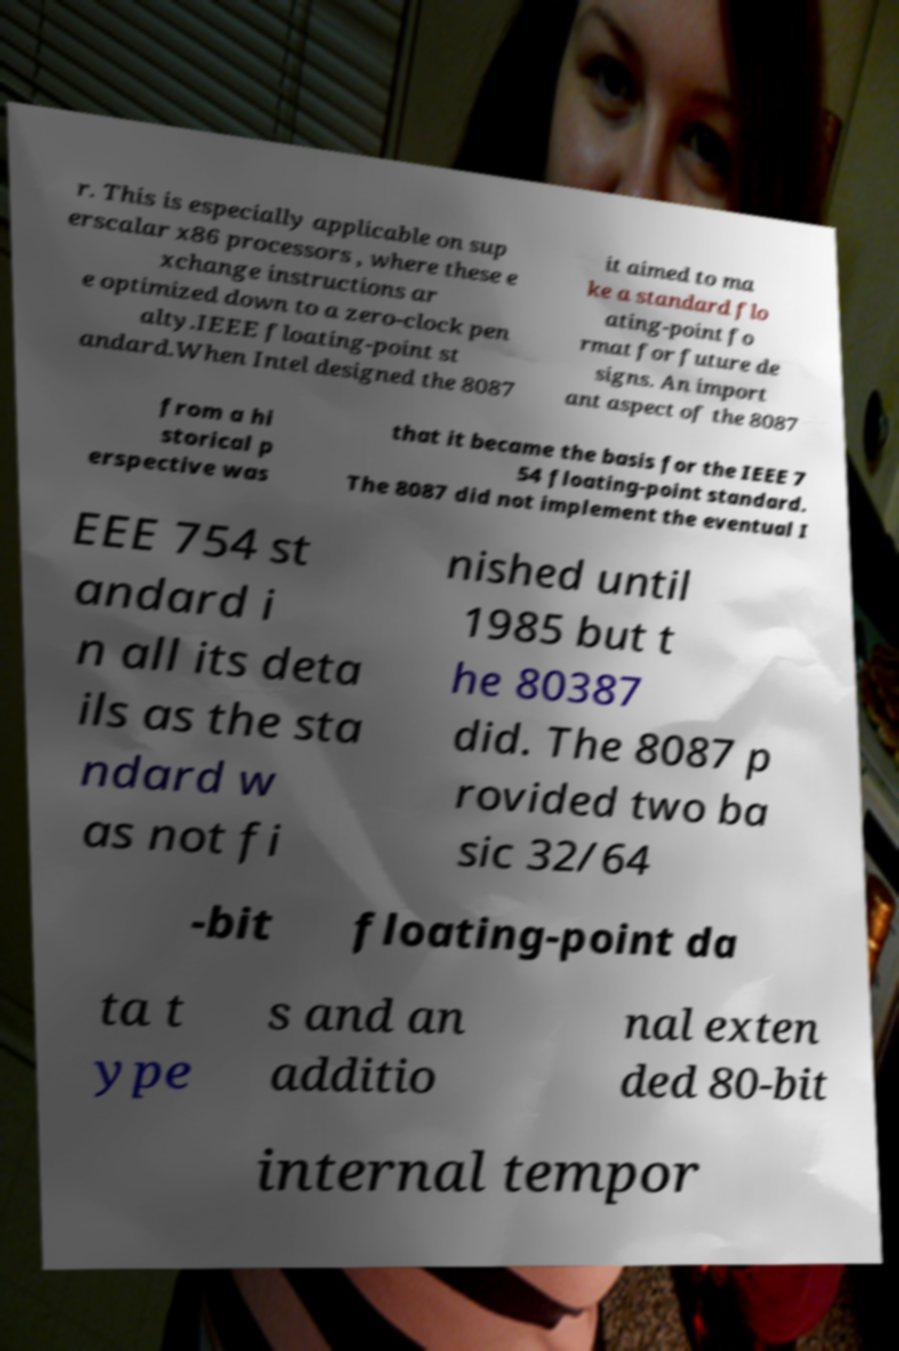For documentation purposes, I need the text within this image transcribed. Could you provide that? r. This is especially applicable on sup erscalar x86 processors , where these e xchange instructions ar e optimized down to a zero-clock pen alty.IEEE floating-point st andard.When Intel designed the 8087 it aimed to ma ke a standard flo ating-point fo rmat for future de signs. An import ant aspect of the 8087 from a hi storical p erspective was that it became the basis for the IEEE 7 54 floating-point standard. The 8087 did not implement the eventual I EEE 754 st andard i n all its deta ils as the sta ndard w as not fi nished until 1985 but t he 80387 did. The 8087 p rovided two ba sic 32/64 -bit floating-point da ta t ype s and an additio nal exten ded 80-bit internal tempor 